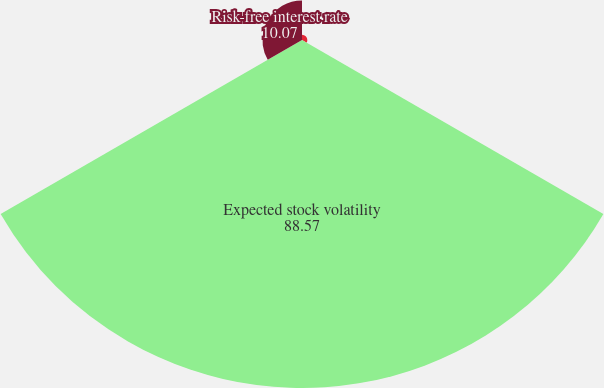Convert chart to OTSL. <chart><loc_0><loc_0><loc_500><loc_500><pie_chart><fcel>Expected dividend yield<fcel>Expected stock volatility<fcel>Risk-free interest rate<nl><fcel>1.36%<fcel>88.57%<fcel>10.07%<nl></chart> 